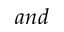Convert formula to latex. <formula><loc_0><loc_0><loc_500><loc_500>a n d</formula> 